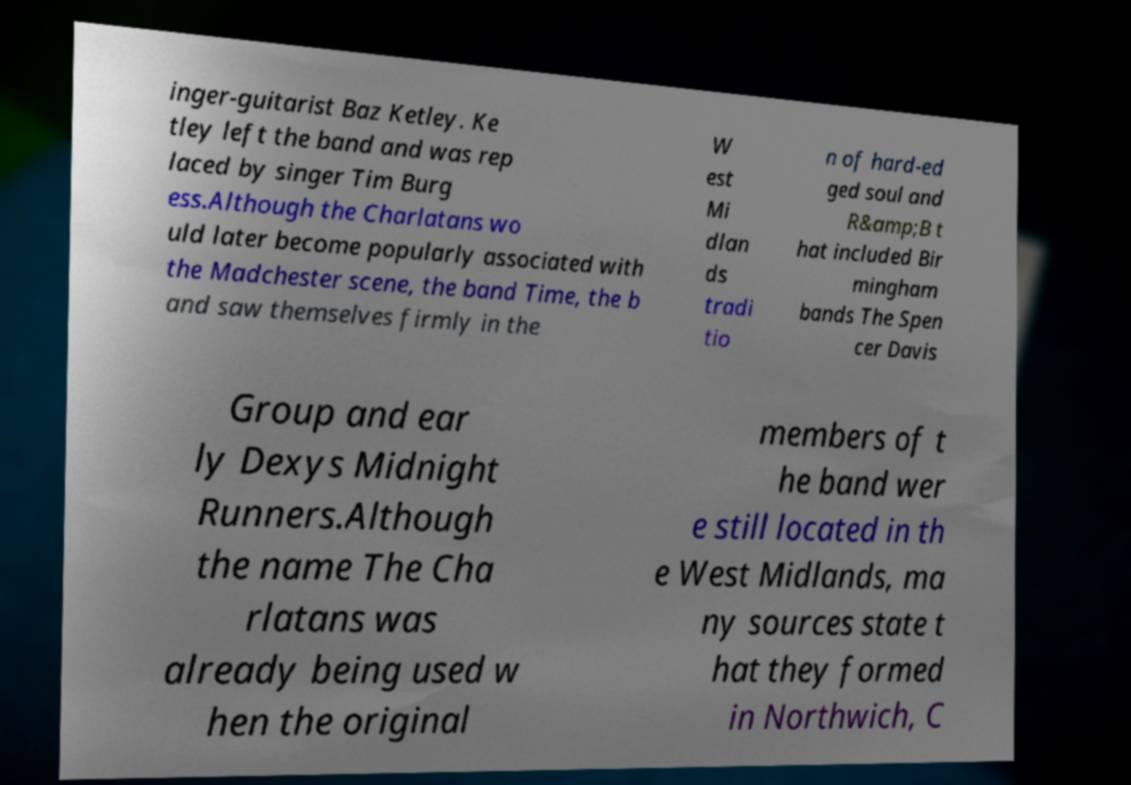Could you assist in decoding the text presented in this image and type it out clearly? inger-guitarist Baz Ketley. Ke tley left the band and was rep laced by singer Tim Burg ess.Although the Charlatans wo uld later become popularly associated with the Madchester scene, the band Time, the b and saw themselves firmly in the W est Mi dlan ds tradi tio n of hard-ed ged soul and R&amp;B t hat included Bir mingham bands The Spen cer Davis Group and ear ly Dexys Midnight Runners.Although the name The Cha rlatans was already being used w hen the original members of t he band wer e still located in th e West Midlands, ma ny sources state t hat they formed in Northwich, C 